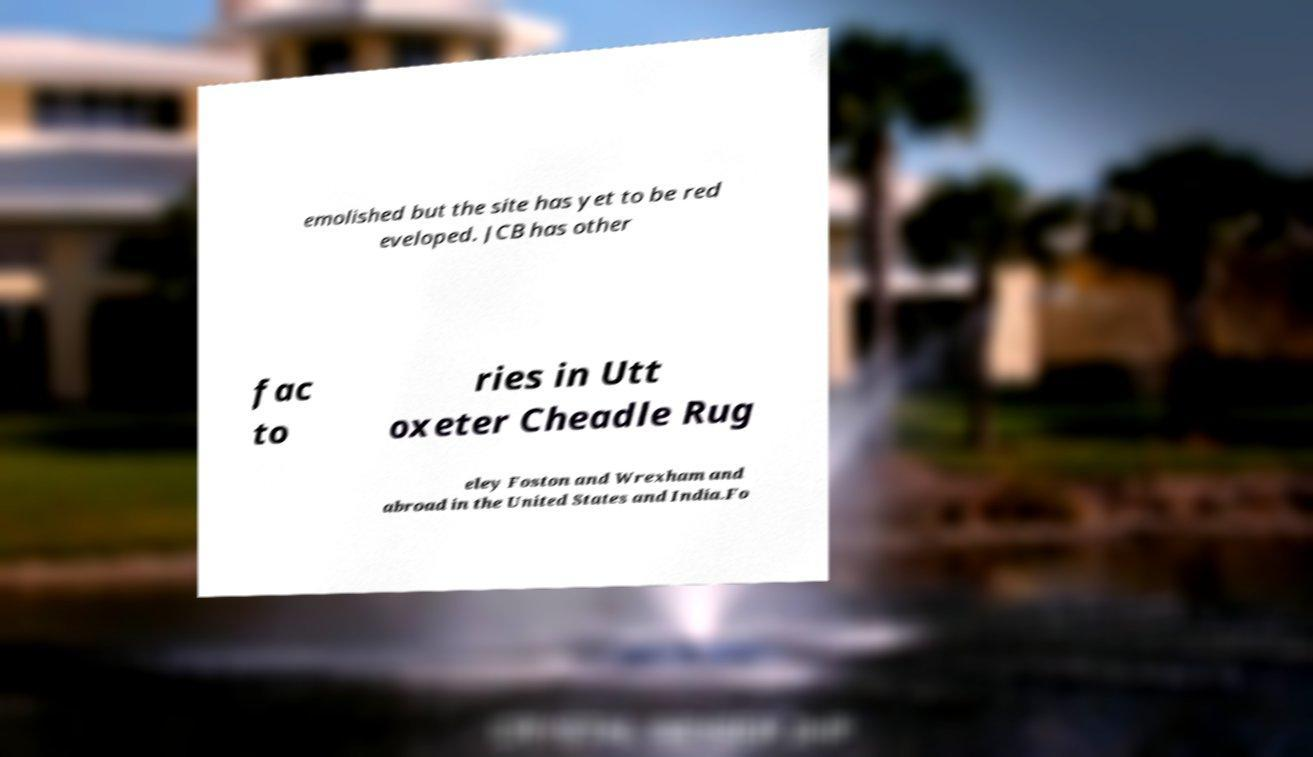Can you accurately transcribe the text from the provided image for me? emolished but the site has yet to be red eveloped. JCB has other fac to ries in Utt oxeter Cheadle Rug eley Foston and Wrexham and abroad in the United States and India.Fo 